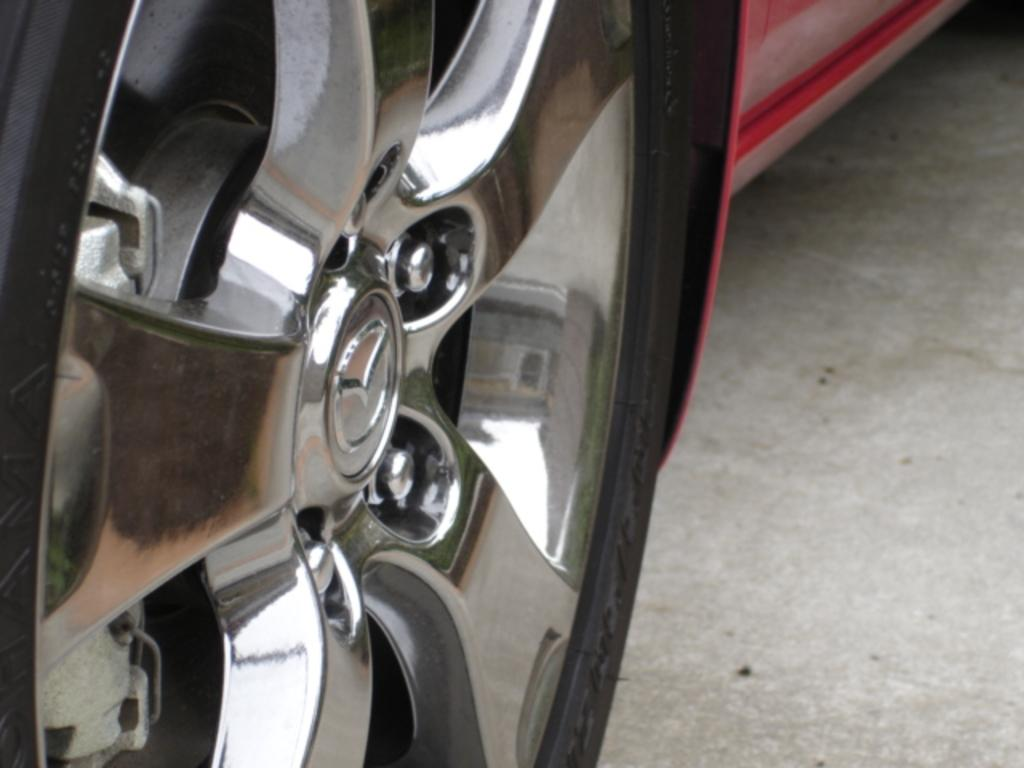What color is the car in the image? The car in the image is red. What type of berry is hanging from the car's rearview mirror in the image? There is no berry present in the image, as it only features a red color car. 